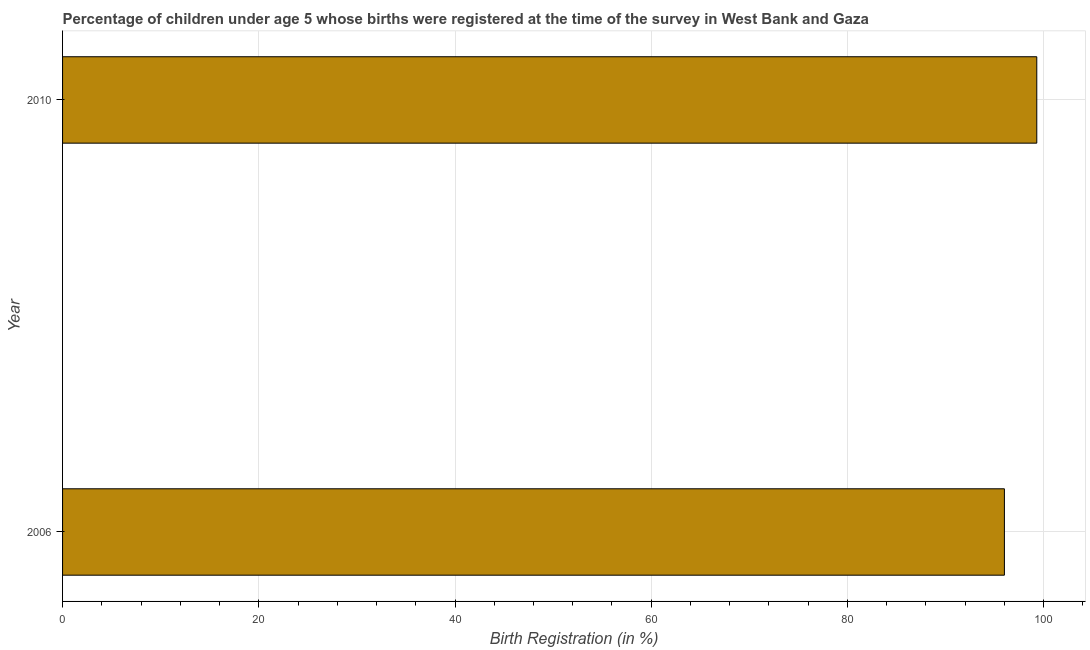What is the title of the graph?
Make the answer very short. Percentage of children under age 5 whose births were registered at the time of the survey in West Bank and Gaza. What is the label or title of the X-axis?
Provide a short and direct response. Birth Registration (in %). What is the label or title of the Y-axis?
Make the answer very short. Year. What is the birth registration in 2010?
Give a very brief answer. 99.3. Across all years, what is the maximum birth registration?
Keep it short and to the point. 99.3. Across all years, what is the minimum birth registration?
Your response must be concise. 96. In which year was the birth registration minimum?
Offer a terse response. 2006. What is the sum of the birth registration?
Your response must be concise. 195.3. What is the difference between the birth registration in 2006 and 2010?
Your answer should be compact. -3.3. What is the average birth registration per year?
Offer a terse response. 97.65. What is the median birth registration?
Provide a short and direct response. 97.65. In how many years, is the birth registration greater than 96 %?
Offer a very short reply. 1. Do a majority of the years between 2006 and 2010 (inclusive) have birth registration greater than 100 %?
Offer a very short reply. No. What is the ratio of the birth registration in 2006 to that in 2010?
Give a very brief answer. 0.97. How many bars are there?
Make the answer very short. 2. How many years are there in the graph?
Offer a terse response. 2. What is the difference between two consecutive major ticks on the X-axis?
Offer a very short reply. 20. Are the values on the major ticks of X-axis written in scientific E-notation?
Offer a terse response. No. What is the Birth Registration (in %) in 2006?
Your answer should be very brief. 96. What is the Birth Registration (in %) of 2010?
Give a very brief answer. 99.3. What is the difference between the Birth Registration (in %) in 2006 and 2010?
Your response must be concise. -3.3. 